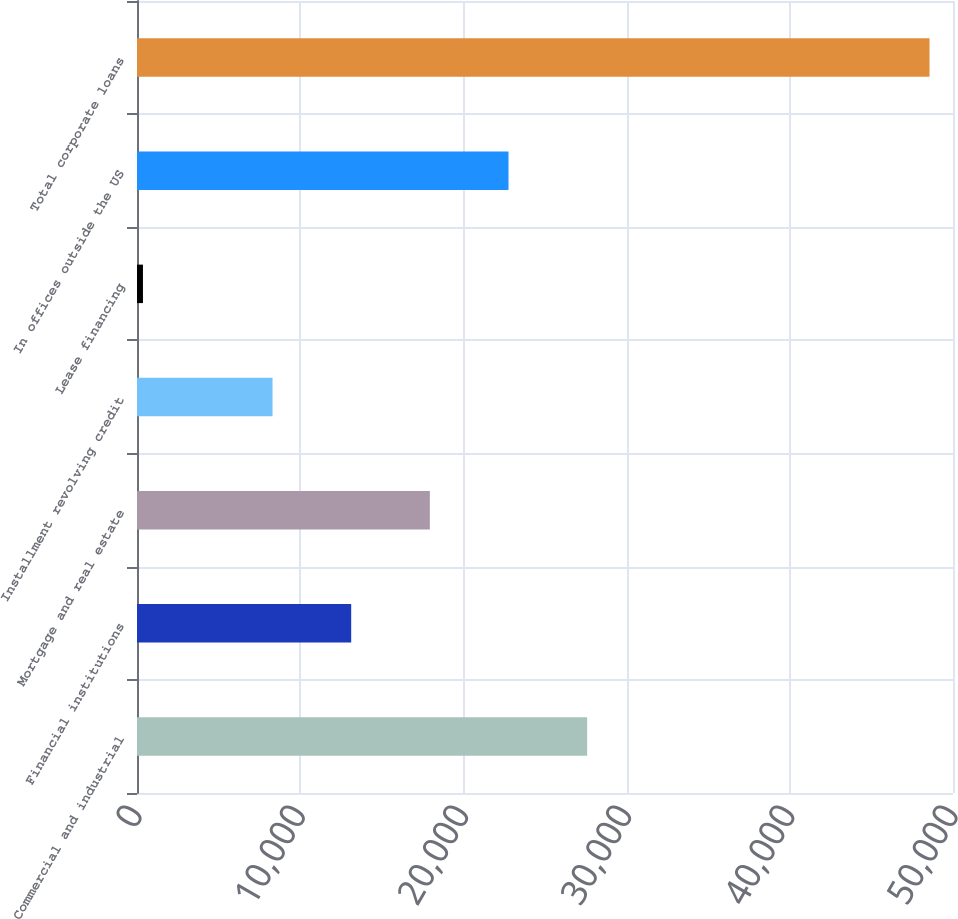<chart> <loc_0><loc_0><loc_500><loc_500><bar_chart><fcel>Commercial and industrial<fcel>Financial institutions<fcel>Mortgage and real estate<fcel>Installment revolving credit<fcel>Lease financing<fcel>In offices outside the US<fcel>Total corporate loans<nl><fcel>27583.4<fcel>13124.6<fcel>17944.2<fcel>8305<fcel>365<fcel>22763.8<fcel>48561<nl></chart> 